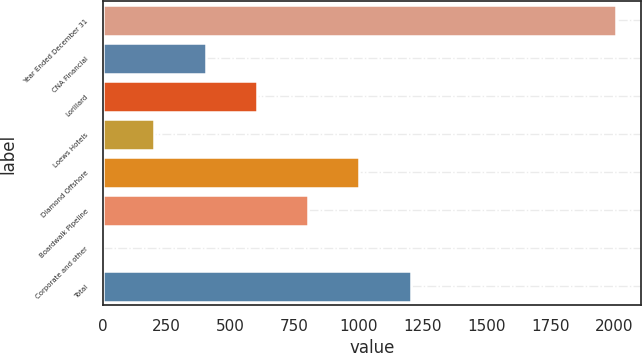<chart> <loc_0><loc_0><loc_500><loc_500><bar_chart><fcel>Year Ended December 31<fcel>CNA Financial<fcel>Lorillard<fcel>Loews Hotels<fcel>Diamond Offshore<fcel>Boardwalk Pipeline<fcel>Corporate and other<fcel>Total<nl><fcel>2005<fcel>402.6<fcel>602.9<fcel>202.3<fcel>1003.5<fcel>803.2<fcel>2<fcel>1203.8<nl></chart> 